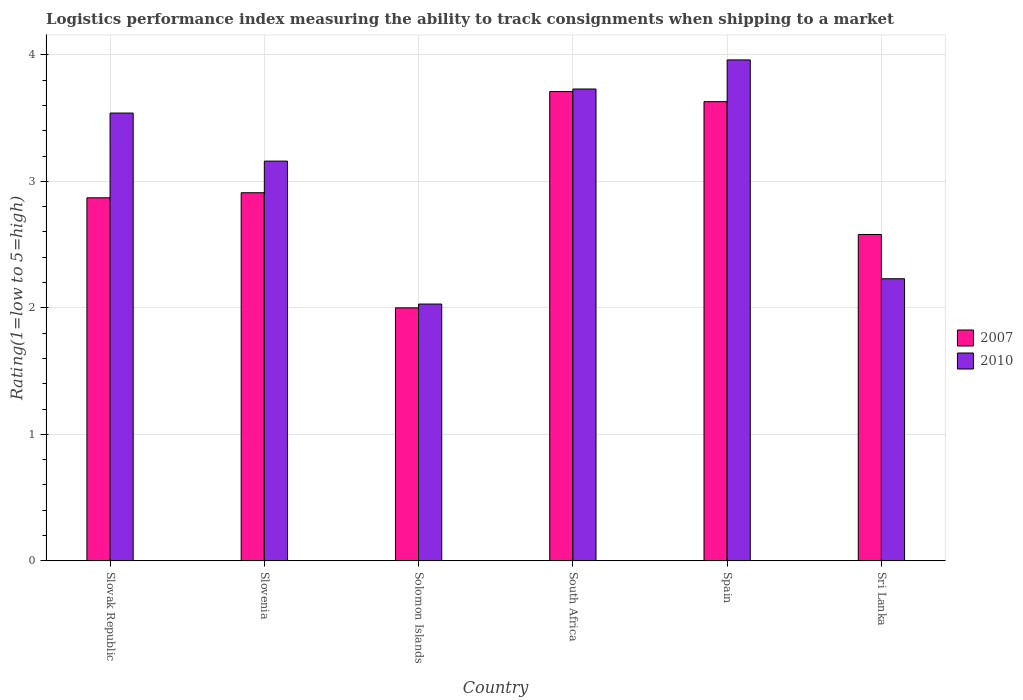How many different coloured bars are there?
Provide a short and direct response. 2. How many bars are there on the 6th tick from the left?
Provide a succinct answer. 2. What is the label of the 2nd group of bars from the left?
Your response must be concise. Slovenia. In how many cases, is the number of bars for a given country not equal to the number of legend labels?
Make the answer very short. 0. What is the Logistic performance index in 2007 in Sri Lanka?
Make the answer very short. 2.58. Across all countries, what is the maximum Logistic performance index in 2007?
Ensure brevity in your answer.  3.71. Across all countries, what is the minimum Logistic performance index in 2010?
Provide a succinct answer. 2.03. In which country was the Logistic performance index in 2007 maximum?
Offer a terse response. South Africa. In which country was the Logistic performance index in 2007 minimum?
Offer a terse response. Solomon Islands. What is the total Logistic performance index in 2007 in the graph?
Provide a succinct answer. 17.7. What is the difference between the Logistic performance index in 2007 in Slovenia and that in Solomon Islands?
Make the answer very short. 0.91. What is the average Logistic performance index in 2010 per country?
Keep it short and to the point. 3.11. What is the difference between the Logistic performance index of/in 2007 and Logistic performance index of/in 2010 in Slovak Republic?
Offer a terse response. -0.67. What is the ratio of the Logistic performance index in 2007 in Slovenia to that in South Africa?
Ensure brevity in your answer.  0.78. Is the Logistic performance index in 2007 in Spain less than that in Sri Lanka?
Your answer should be very brief. No. Is the difference between the Logistic performance index in 2007 in South Africa and Spain greater than the difference between the Logistic performance index in 2010 in South Africa and Spain?
Offer a very short reply. Yes. What is the difference between the highest and the second highest Logistic performance index in 2007?
Provide a succinct answer. 0.72. What is the difference between the highest and the lowest Logistic performance index in 2007?
Ensure brevity in your answer.  1.71. What does the 1st bar from the right in Spain represents?
Your response must be concise. 2010. Are all the bars in the graph horizontal?
Your answer should be very brief. No. What is the difference between two consecutive major ticks on the Y-axis?
Give a very brief answer. 1. Are the values on the major ticks of Y-axis written in scientific E-notation?
Offer a terse response. No. Does the graph contain any zero values?
Offer a very short reply. No. Where does the legend appear in the graph?
Your response must be concise. Center right. How are the legend labels stacked?
Keep it short and to the point. Vertical. What is the title of the graph?
Provide a short and direct response. Logistics performance index measuring the ability to track consignments when shipping to a market. Does "1960" appear as one of the legend labels in the graph?
Provide a succinct answer. No. What is the label or title of the X-axis?
Offer a terse response. Country. What is the label or title of the Y-axis?
Offer a very short reply. Rating(1=low to 5=high). What is the Rating(1=low to 5=high) of 2007 in Slovak Republic?
Provide a succinct answer. 2.87. What is the Rating(1=low to 5=high) in 2010 in Slovak Republic?
Your answer should be compact. 3.54. What is the Rating(1=low to 5=high) of 2007 in Slovenia?
Offer a very short reply. 2.91. What is the Rating(1=low to 5=high) of 2010 in Slovenia?
Give a very brief answer. 3.16. What is the Rating(1=low to 5=high) of 2007 in Solomon Islands?
Provide a short and direct response. 2. What is the Rating(1=low to 5=high) in 2010 in Solomon Islands?
Make the answer very short. 2.03. What is the Rating(1=low to 5=high) of 2007 in South Africa?
Make the answer very short. 3.71. What is the Rating(1=low to 5=high) of 2010 in South Africa?
Offer a terse response. 3.73. What is the Rating(1=low to 5=high) of 2007 in Spain?
Your answer should be very brief. 3.63. What is the Rating(1=low to 5=high) in 2010 in Spain?
Provide a short and direct response. 3.96. What is the Rating(1=low to 5=high) of 2007 in Sri Lanka?
Offer a terse response. 2.58. What is the Rating(1=low to 5=high) of 2010 in Sri Lanka?
Offer a terse response. 2.23. Across all countries, what is the maximum Rating(1=low to 5=high) of 2007?
Ensure brevity in your answer.  3.71. Across all countries, what is the maximum Rating(1=low to 5=high) in 2010?
Make the answer very short. 3.96. Across all countries, what is the minimum Rating(1=low to 5=high) in 2007?
Your response must be concise. 2. Across all countries, what is the minimum Rating(1=low to 5=high) of 2010?
Provide a succinct answer. 2.03. What is the total Rating(1=low to 5=high) in 2007 in the graph?
Your answer should be very brief. 17.7. What is the total Rating(1=low to 5=high) in 2010 in the graph?
Provide a succinct answer. 18.65. What is the difference between the Rating(1=low to 5=high) of 2007 in Slovak Republic and that in Slovenia?
Provide a short and direct response. -0.04. What is the difference between the Rating(1=low to 5=high) in 2010 in Slovak Republic and that in Slovenia?
Your answer should be compact. 0.38. What is the difference between the Rating(1=low to 5=high) of 2007 in Slovak Republic and that in Solomon Islands?
Provide a short and direct response. 0.87. What is the difference between the Rating(1=low to 5=high) in 2010 in Slovak Republic and that in Solomon Islands?
Provide a short and direct response. 1.51. What is the difference between the Rating(1=low to 5=high) of 2007 in Slovak Republic and that in South Africa?
Your answer should be compact. -0.84. What is the difference between the Rating(1=low to 5=high) in 2010 in Slovak Republic and that in South Africa?
Offer a terse response. -0.19. What is the difference between the Rating(1=low to 5=high) in 2007 in Slovak Republic and that in Spain?
Provide a succinct answer. -0.76. What is the difference between the Rating(1=low to 5=high) in 2010 in Slovak Republic and that in Spain?
Provide a short and direct response. -0.42. What is the difference between the Rating(1=low to 5=high) of 2007 in Slovak Republic and that in Sri Lanka?
Your answer should be compact. 0.29. What is the difference between the Rating(1=low to 5=high) in 2010 in Slovak Republic and that in Sri Lanka?
Ensure brevity in your answer.  1.31. What is the difference between the Rating(1=low to 5=high) of 2007 in Slovenia and that in Solomon Islands?
Your answer should be very brief. 0.91. What is the difference between the Rating(1=low to 5=high) in 2010 in Slovenia and that in Solomon Islands?
Provide a succinct answer. 1.13. What is the difference between the Rating(1=low to 5=high) of 2007 in Slovenia and that in South Africa?
Your response must be concise. -0.8. What is the difference between the Rating(1=low to 5=high) of 2010 in Slovenia and that in South Africa?
Your response must be concise. -0.57. What is the difference between the Rating(1=low to 5=high) of 2007 in Slovenia and that in Spain?
Your response must be concise. -0.72. What is the difference between the Rating(1=low to 5=high) of 2007 in Slovenia and that in Sri Lanka?
Your answer should be very brief. 0.33. What is the difference between the Rating(1=low to 5=high) in 2007 in Solomon Islands and that in South Africa?
Give a very brief answer. -1.71. What is the difference between the Rating(1=low to 5=high) in 2010 in Solomon Islands and that in South Africa?
Ensure brevity in your answer.  -1.7. What is the difference between the Rating(1=low to 5=high) in 2007 in Solomon Islands and that in Spain?
Offer a very short reply. -1.63. What is the difference between the Rating(1=low to 5=high) of 2010 in Solomon Islands and that in Spain?
Give a very brief answer. -1.93. What is the difference between the Rating(1=low to 5=high) in 2007 in Solomon Islands and that in Sri Lanka?
Offer a very short reply. -0.58. What is the difference between the Rating(1=low to 5=high) in 2010 in South Africa and that in Spain?
Ensure brevity in your answer.  -0.23. What is the difference between the Rating(1=low to 5=high) of 2007 in South Africa and that in Sri Lanka?
Your response must be concise. 1.13. What is the difference between the Rating(1=low to 5=high) of 2010 in South Africa and that in Sri Lanka?
Your answer should be very brief. 1.5. What is the difference between the Rating(1=low to 5=high) in 2010 in Spain and that in Sri Lanka?
Ensure brevity in your answer.  1.73. What is the difference between the Rating(1=low to 5=high) in 2007 in Slovak Republic and the Rating(1=low to 5=high) in 2010 in Slovenia?
Offer a terse response. -0.29. What is the difference between the Rating(1=low to 5=high) in 2007 in Slovak Republic and the Rating(1=low to 5=high) in 2010 in Solomon Islands?
Your answer should be very brief. 0.84. What is the difference between the Rating(1=low to 5=high) of 2007 in Slovak Republic and the Rating(1=low to 5=high) of 2010 in South Africa?
Give a very brief answer. -0.86. What is the difference between the Rating(1=low to 5=high) in 2007 in Slovak Republic and the Rating(1=low to 5=high) in 2010 in Spain?
Offer a very short reply. -1.09. What is the difference between the Rating(1=low to 5=high) of 2007 in Slovak Republic and the Rating(1=low to 5=high) of 2010 in Sri Lanka?
Make the answer very short. 0.64. What is the difference between the Rating(1=low to 5=high) of 2007 in Slovenia and the Rating(1=low to 5=high) of 2010 in Solomon Islands?
Your answer should be compact. 0.88. What is the difference between the Rating(1=low to 5=high) in 2007 in Slovenia and the Rating(1=low to 5=high) in 2010 in South Africa?
Make the answer very short. -0.82. What is the difference between the Rating(1=low to 5=high) in 2007 in Slovenia and the Rating(1=low to 5=high) in 2010 in Spain?
Your answer should be very brief. -1.05. What is the difference between the Rating(1=low to 5=high) in 2007 in Slovenia and the Rating(1=low to 5=high) in 2010 in Sri Lanka?
Keep it short and to the point. 0.68. What is the difference between the Rating(1=low to 5=high) in 2007 in Solomon Islands and the Rating(1=low to 5=high) in 2010 in South Africa?
Give a very brief answer. -1.73. What is the difference between the Rating(1=low to 5=high) of 2007 in Solomon Islands and the Rating(1=low to 5=high) of 2010 in Spain?
Your response must be concise. -1.96. What is the difference between the Rating(1=low to 5=high) of 2007 in Solomon Islands and the Rating(1=low to 5=high) of 2010 in Sri Lanka?
Give a very brief answer. -0.23. What is the difference between the Rating(1=low to 5=high) of 2007 in South Africa and the Rating(1=low to 5=high) of 2010 in Sri Lanka?
Offer a very short reply. 1.48. What is the difference between the Rating(1=low to 5=high) in 2007 in Spain and the Rating(1=low to 5=high) in 2010 in Sri Lanka?
Give a very brief answer. 1.4. What is the average Rating(1=low to 5=high) in 2007 per country?
Give a very brief answer. 2.95. What is the average Rating(1=low to 5=high) in 2010 per country?
Provide a succinct answer. 3.11. What is the difference between the Rating(1=low to 5=high) in 2007 and Rating(1=low to 5=high) in 2010 in Slovak Republic?
Offer a terse response. -0.67. What is the difference between the Rating(1=low to 5=high) of 2007 and Rating(1=low to 5=high) of 2010 in Slovenia?
Offer a terse response. -0.25. What is the difference between the Rating(1=low to 5=high) in 2007 and Rating(1=low to 5=high) in 2010 in Solomon Islands?
Offer a very short reply. -0.03. What is the difference between the Rating(1=low to 5=high) in 2007 and Rating(1=low to 5=high) in 2010 in South Africa?
Make the answer very short. -0.02. What is the difference between the Rating(1=low to 5=high) of 2007 and Rating(1=low to 5=high) of 2010 in Spain?
Offer a terse response. -0.33. What is the difference between the Rating(1=low to 5=high) in 2007 and Rating(1=low to 5=high) in 2010 in Sri Lanka?
Keep it short and to the point. 0.35. What is the ratio of the Rating(1=low to 5=high) in 2007 in Slovak Republic to that in Slovenia?
Your answer should be compact. 0.99. What is the ratio of the Rating(1=low to 5=high) of 2010 in Slovak Republic to that in Slovenia?
Make the answer very short. 1.12. What is the ratio of the Rating(1=low to 5=high) in 2007 in Slovak Republic to that in Solomon Islands?
Offer a terse response. 1.44. What is the ratio of the Rating(1=low to 5=high) in 2010 in Slovak Republic to that in Solomon Islands?
Provide a short and direct response. 1.74. What is the ratio of the Rating(1=low to 5=high) in 2007 in Slovak Republic to that in South Africa?
Ensure brevity in your answer.  0.77. What is the ratio of the Rating(1=low to 5=high) in 2010 in Slovak Republic to that in South Africa?
Your answer should be very brief. 0.95. What is the ratio of the Rating(1=low to 5=high) in 2007 in Slovak Republic to that in Spain?
Offer a very short reply. 0.79. What is the ratio of the Rating(1=low to 5=high) of 2010 in Slovak Republic to that in Spain?
Offer a very short reply. 0.89. What is the ratio of the Rating(1=low to 5=high) of 2007 in Slovak Republic to that in Sri Lanka?
Your answer should be very brief. 1.11. What is the ratio of the Rating(1=low to 5=high) in 2010 in Slovak Republic to that in Sri Lanka?
Provide a succinct answer. 1.59. What is the ratio of the Rating(1=low to 5=high) in 2007 in Slovenia to that in Solomon Islands?
Offer a terse response. 1.46. What is the ratio of the Rating(1=low to 5=high) of 2010 in Slovenia to that in Solomon Islands?
Your response must be concise. 1.56. What is the ratio of the Rating(1=low to 5=high) in 2007 in Slovenia to that in South Africa?
Your response must be concise. 0.78. What is the ratio of the Rating(1=low to 5=high) in 2010 in Slovenia to that in South Africa?
Make the answer very short. 0.85. What is the ratio of the Rating(1=low to 5=high) of 2007 in Slovenia to that in Spain?
Your answer should be compact. 0.8. What is the ratio of the Rating(1=low to 5=high) in 2010 in Slovenia to that in Spain?
Provide a succinct answer. 0.8. What is the ratio of the Rating(1=low to 5=high) of 2007 in Slovenia to that in Sri Lanka?
Give a very brief answer. 1.13. What is the ratio of the Rating(1=low to 5=high) in 2010 in Slovenia to that in Sri Lanka?
Keep it short and to the point. 1.42. What is the ratio of the Rating(1=low to 5=high) of 2007 in Solomon Islands to that in South Africa?
Offer a terse response. 0.54. What is the ratio of the Rating(1=low to 5=high) of 2010 in Solomon Islands to that in South Africa?
Offer a terse response. 0.54. What is the ratio of the Rating(1=low to 5=high) in 2007 in Solomon Islands to that in Spain?
Your answer should be very brief. 0.55. What is the ratio of the Rating(1=low to 5=high) of 2010 in Solomon Islands to that in Spain?
Your answer should be compact. 0.51. What is the ratio of the Rating(1=low to 5=high) in 2007 in Solomon Islands to that in Sri Lanka?
Offer a very short reply. 0.78. What is the ratio of the Rating(1=low to 5=high) in 2010 in Solomon Islands to that in Sri Lanka?
Your answer should be very brief. 0.91. What is the ratio of the Rating(1=low to 5=high) of 2010 in South Africa to that in Spain?
Keep it short and to the point. 0.94. What is the ratio of the Rating(1=low to 5=high) in 2007 in South Africa to that in Sri Lanka?
Your response must be concise. 1.44. What is the ratio of the Rating(1=low to 5=high) in 2010 in South Africa to that in Sri Lanka?
Keep it short and to the point. 1.67. What is the ratio of the Rating(1=low to 5=high) in 2007 in Spain to that in Sri Lanka?
Keep it short and to the point. 1.41. What is the ratio of the Rating(1=low to 5=high) of 2010 in Spain to that in Sri Lanka?
Your response must be concise. 1.78. What is the difference between the highest and the second highest Rating(1=low to 5=high) in 2007?
Your response must be concise. 0.08. What is the difference between the highest and the second highest Rating(1=low to 5=high) of 2010?
Your answer should be compact. 0.23. What is the difference between the highest and the lowest Rating(1=low to 5=high) in 2007?
Offer a very short reply. 1.71. What is the difference between the highest and the lowest Rating(1=low to 5=high) of 2010?
Offer a very short reply. 1.93. 